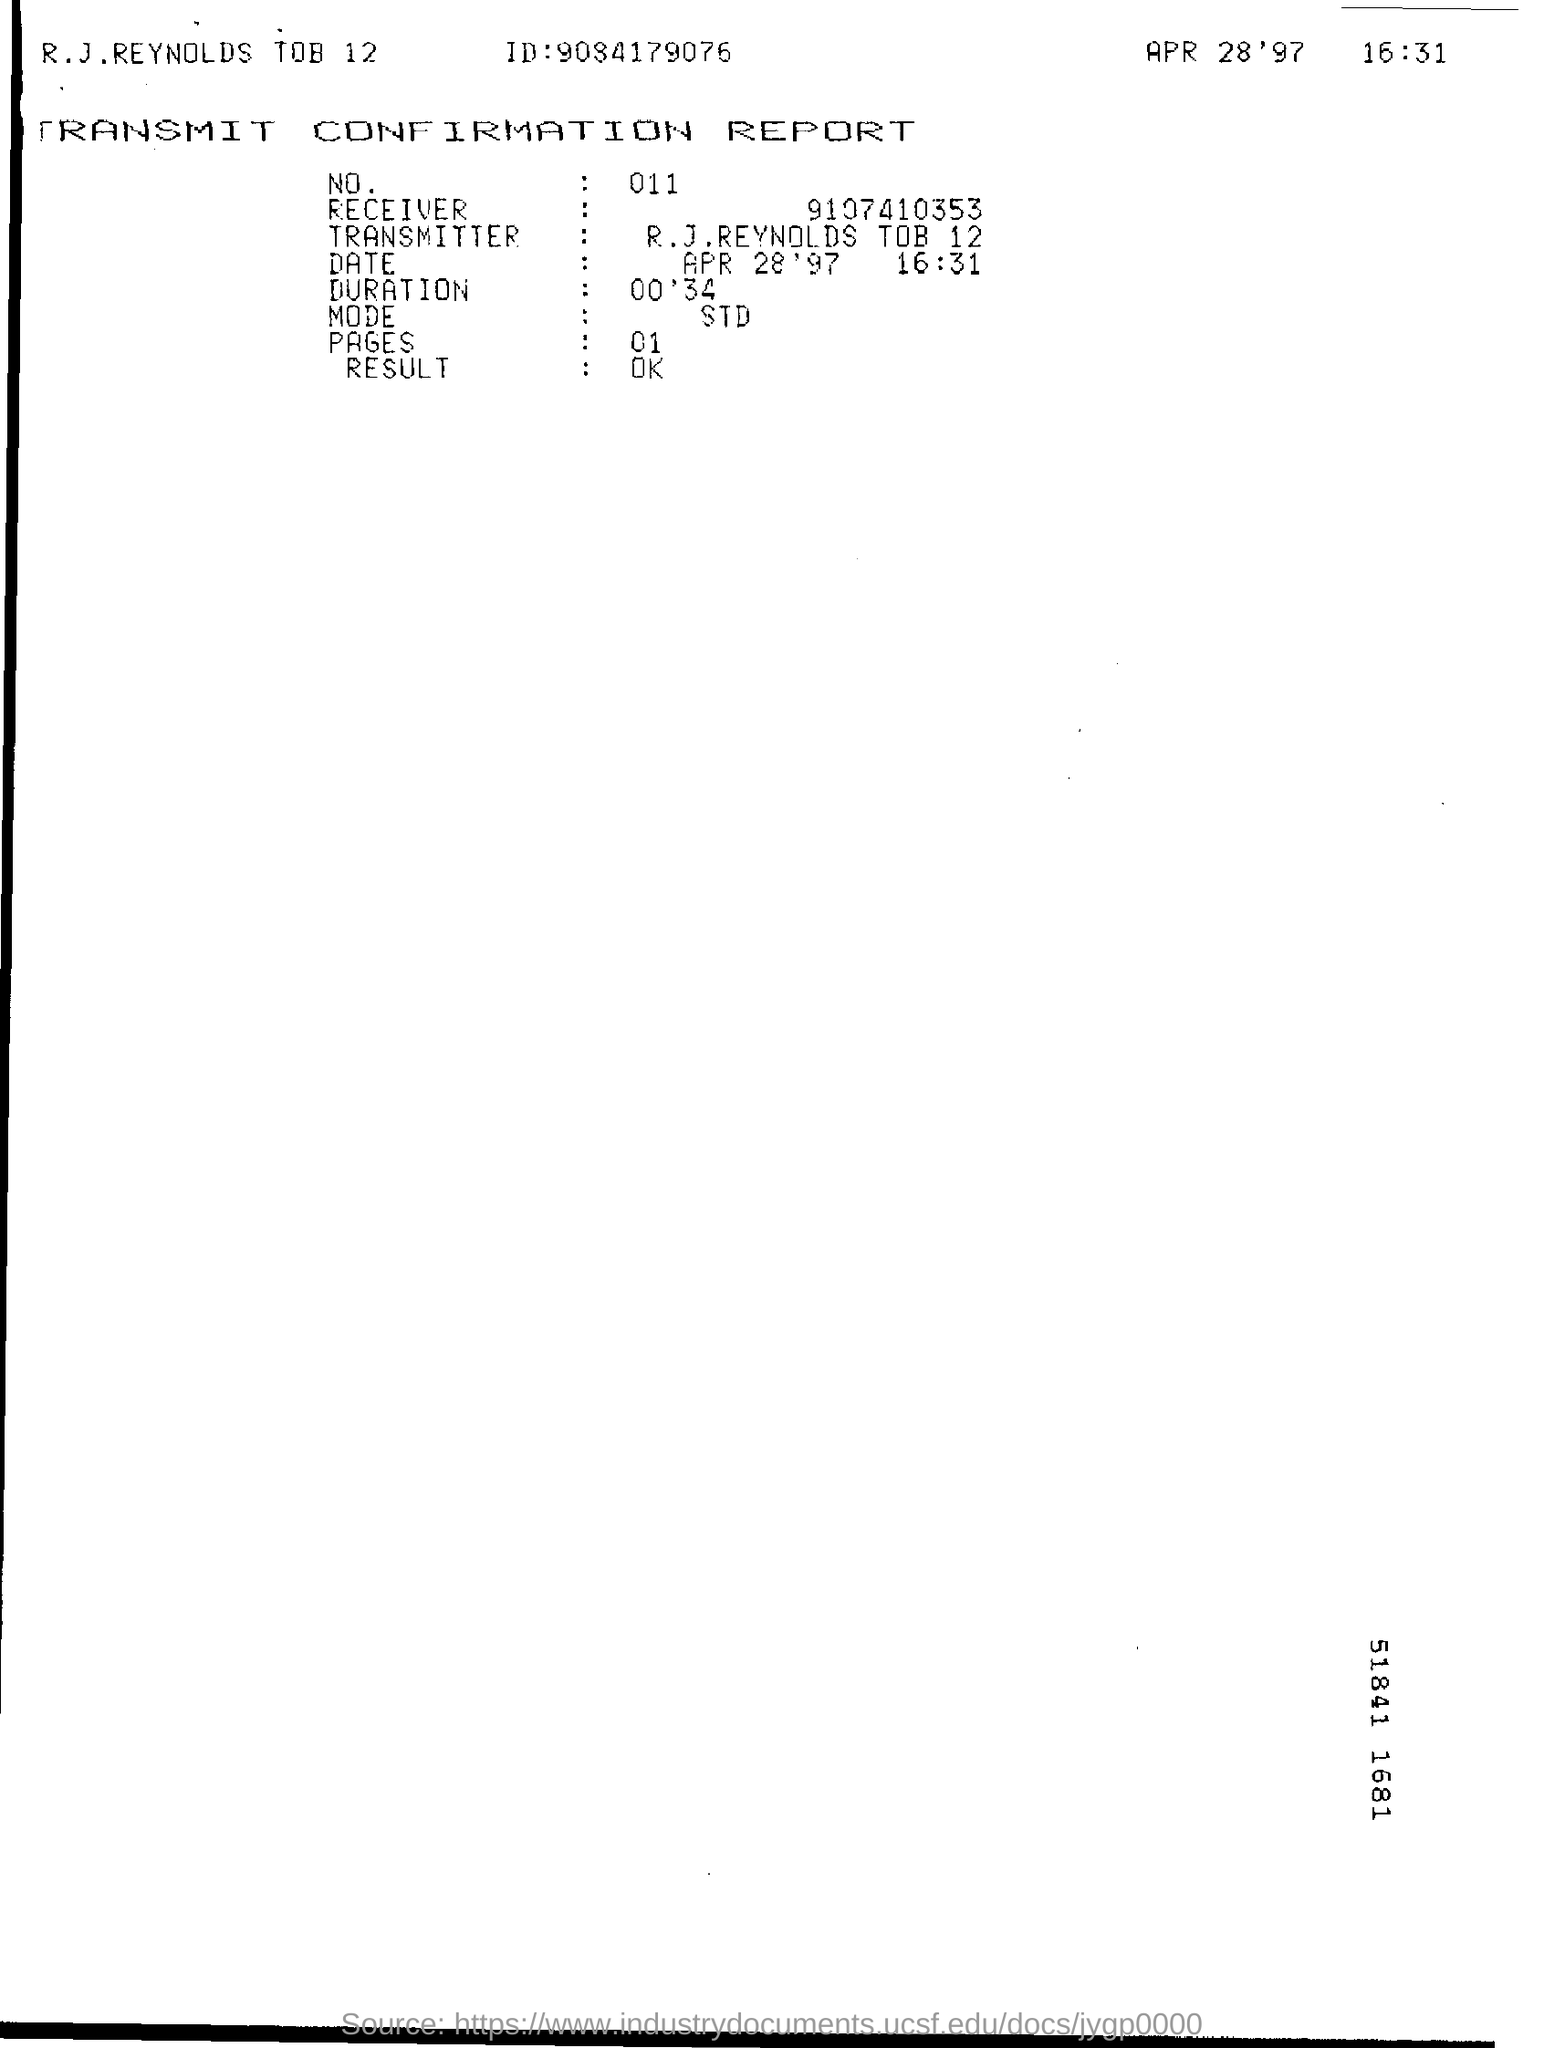Specify some key components in this picture. The number on the report is 011... This is a declaration that states the type of documentation being referred to is a "Transmit Confirmation Report. The ID mentioned in the report is 9084179076. What is the mode mentioned? It is a declaration that requires a standard deviation. The document is dated April 28, 1997. 